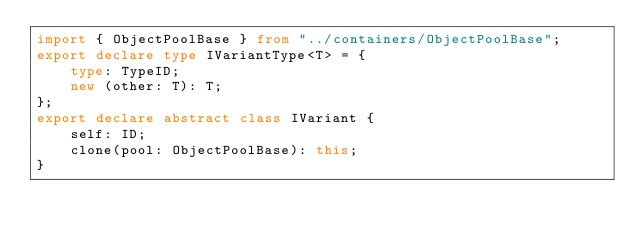<code> <loc_0><loc_0><loc_500><loc_500><_TypeScript_>import { ObjectPoolBase } from "../containers/ObjectPoolBase";
export declare type IVariantType<T> = {
    type: TypeID;
    new (other: T): T;
};
export declare abstract class IVariant {
    self: ID;
    clone(pool: ObjectPoolBase): this;
}
</code> 